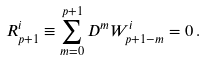<formula> <loc_0><loc_0><loc_500><loc_500>R ^ { i } _ { p + 1 } \equiv \sum _ { m = 0 } ^ { p + 1 } D ^ { m } W ^ { i } _ { p + 1 - m } = 0 \, .</formula> 